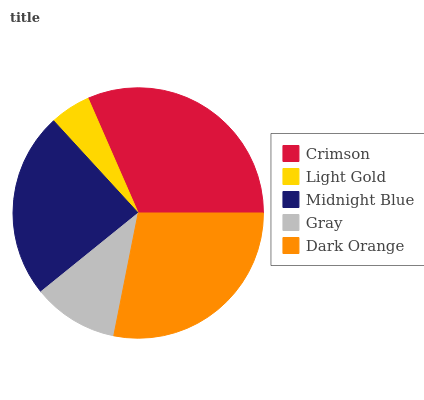Is Light Gold the minimum?
Answer yes or no. Yes. Is Crimson the maximum?
Answer yes or no. Yes. Is Midnight Blue the minimum?
Answer yes or no. No. Is Midnight Blue the maximum?
Answer yes or no. No. Is Midnight Blue greater than Light Gold?
Answer yes or no. Yes. Is Light Gold less than Midnight Blue?
Answer yes or no. Yes. Is Light Gold greater than Midnight Blue?
Answer yes or no. No. Is Midnight Blue less than Light Gold?
Answer yes or no. No. Is Midnight Blue the high median?
Answer yes or no. Yes. Is Midnight Blue the low median?
Answer yes or no. Yes. Is Crimson the high median?
Answer yes or no. No. Is Gray the low median?
Answer yes or no. No. 